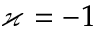<formula> <loc_0><loc_0><loc_500><loc_500>\varkappa = - 1</formula> 